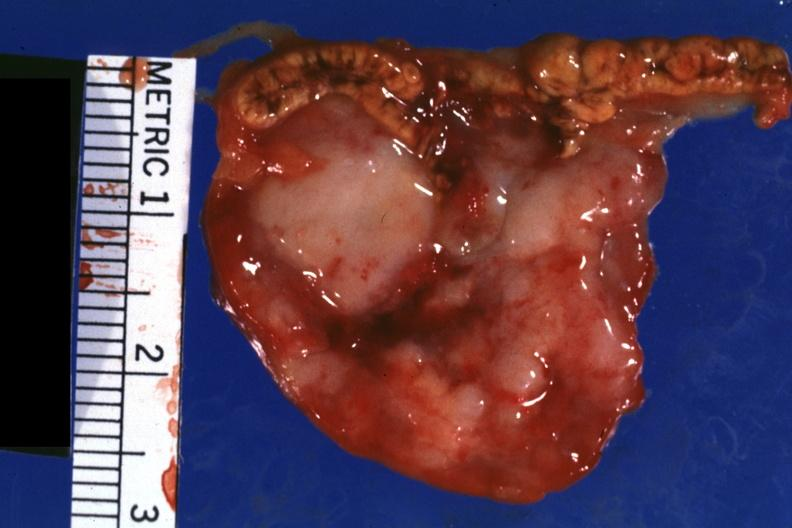s metastatic carcinoma oat cell present?
Answer the question using a single word or phrase. Yes 